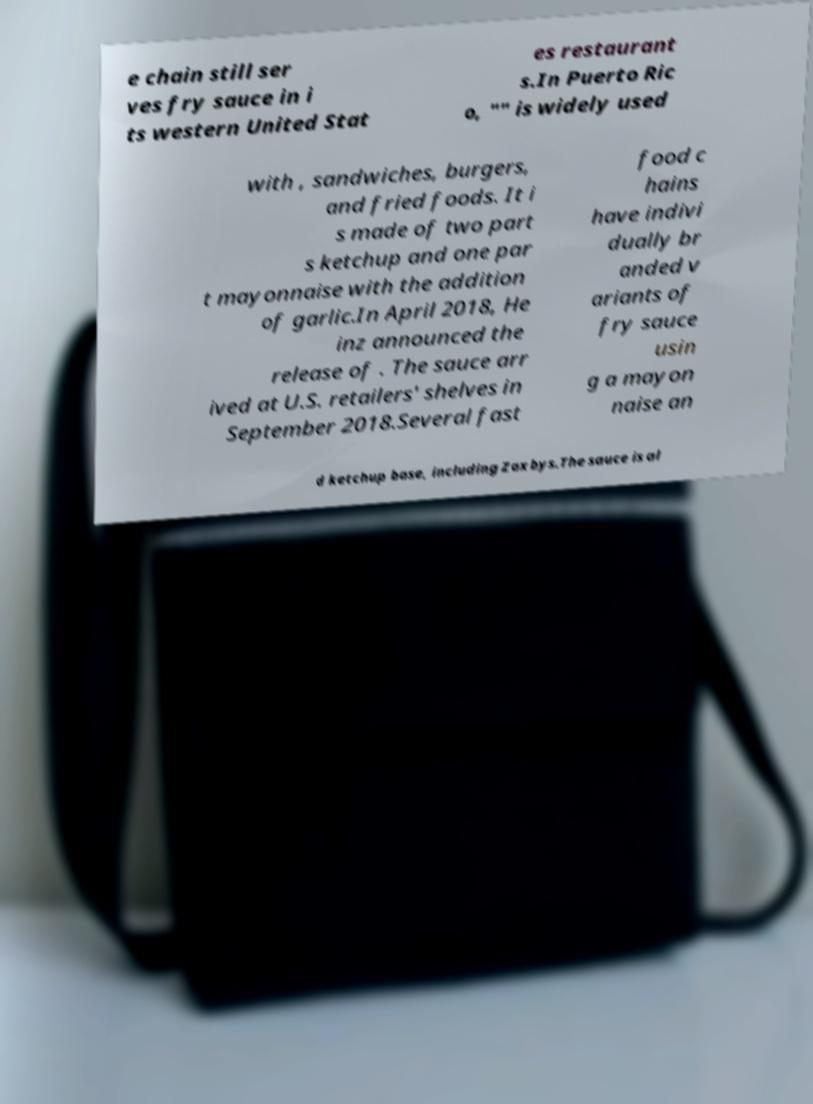I need the written content from this picture converted into text. Can you do that? e chain still ser ves fry sauce in i ts western United Stat es restaurant s.In Puerto Ric o, "" is widely used with , sandwiches, burgers, and fried foods. It i s made of two part s ketchup and one par t mayonnaise with the addition of garlic.In April 2018, He inz announced the release of . The sauce arr ived at U.S. retailers' shelves in September 2018.Several fast food c hains have indivi dually br anded v ariants of fry sauce usin g a mayon naise an d ketchup base, including Zaxbys.The sauce is al 